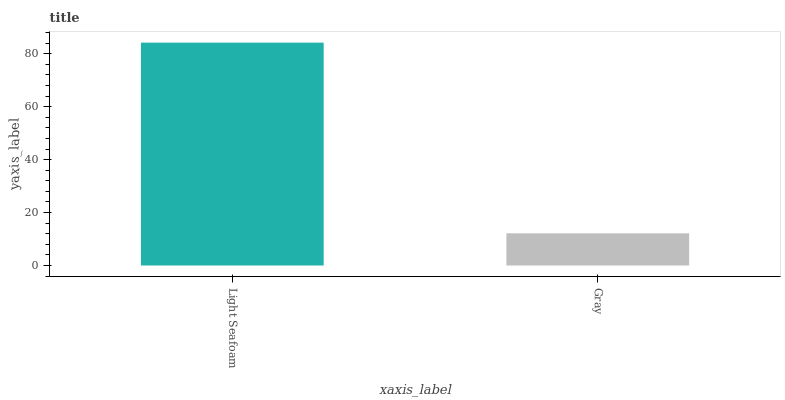Is Gray the minimum?
Answer yes or no. Yes. Is Light Seafoam the maximum?
Answer yes or no. Yes. Is Gray the maximum?
Answer yes or no. No. Is Light Seafoam greater than Gray?
Answer yes or no. Yes. Is Gray less than Light Seafoam?
Answer yes or no. Yes. Is Gray greater than Light Seafoam?
Answer yes or no. No. Is Light Seafoam less than Gray?
Answer yes or no. No. Is Light Seafoam the high median?
Answer yes or no. Yes. Is Gray the low median?
Answer yes or no. Yes. Is Gray the high median?
Answer yes or no. No. Is Light Seafoam the low median?
Answer yes or no. No. 